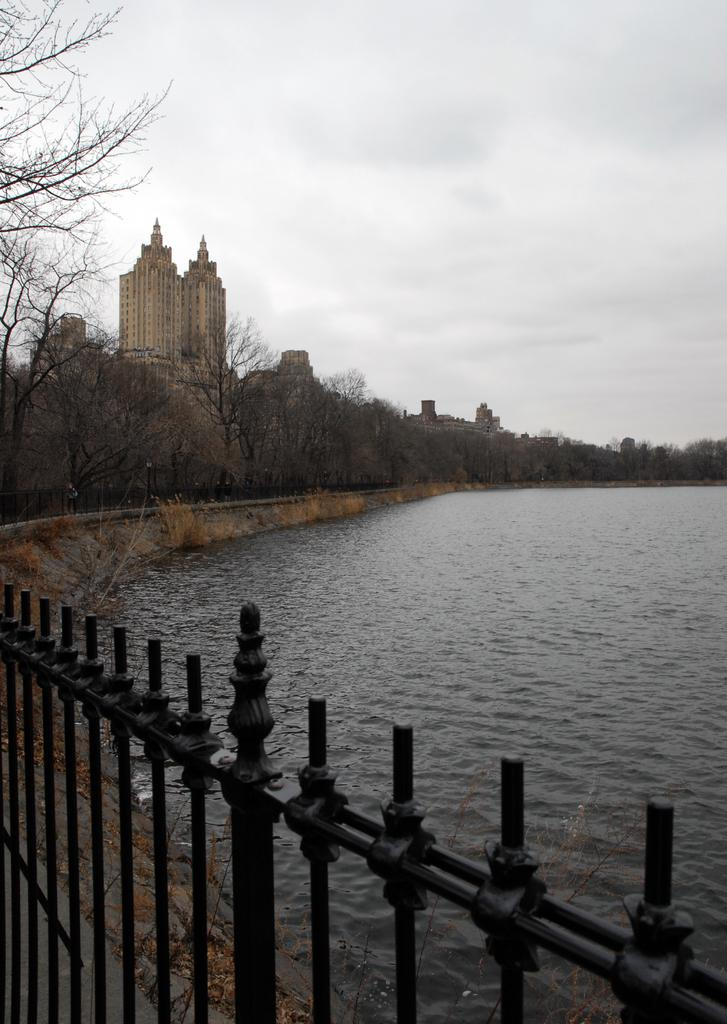What type of structures can be seen in the image? There are buildings in the image. What can be found on the river bank in the image? There are trees on the river bank in the image. What type of barrier is present in the image? There is fencing in the image. What part of the natural environment is visible in the image? The sky is visible in the image. Where is the scarecrow located in the image? There is no scarecrow present in the image. What type of curve can be seen in the image? The image does not depict any curves; it shows buildings, trees, fencing, and the sky. 